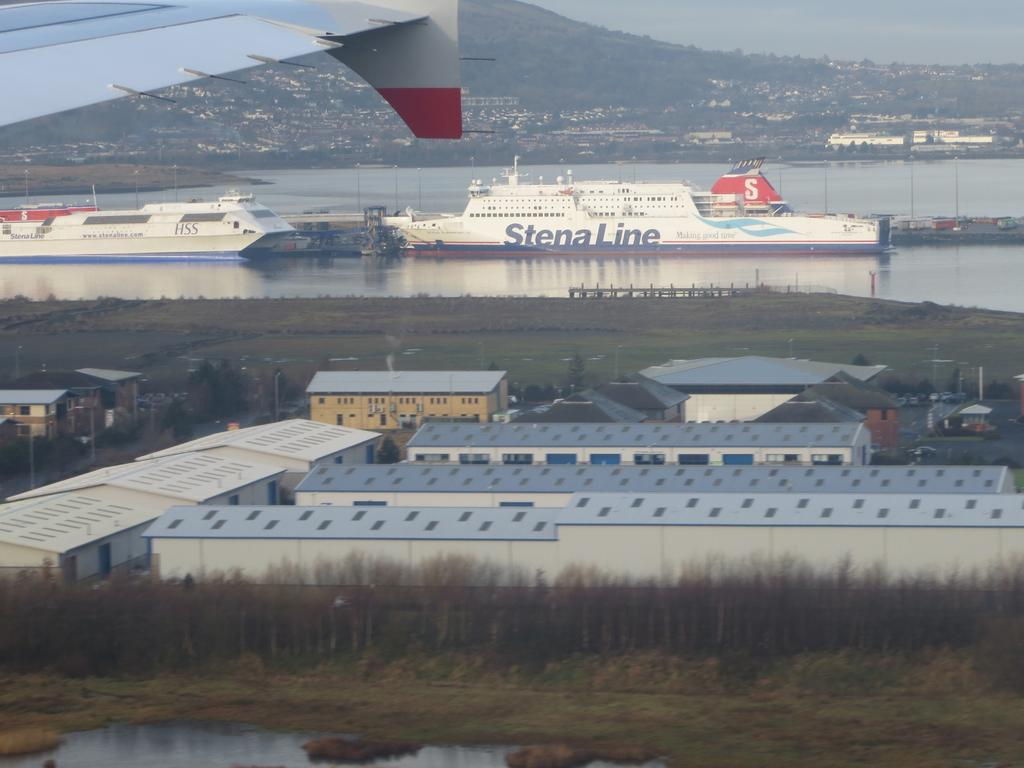Provide a one-sentence caption for the provided image. A Stena Line ship is sailing in the distance. 